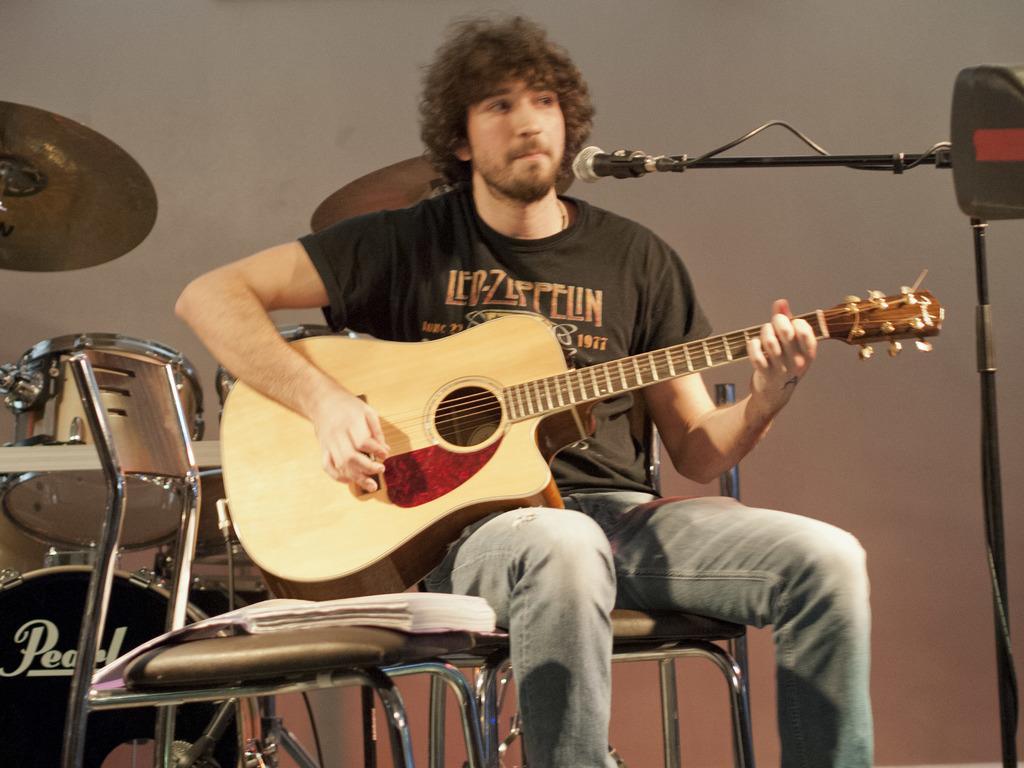Describe this image in one or two sentences. A man with black t-shirt is sitting on a chair and playing guitar. In front of his mouth there is a mic. At the back of him there are some musical instruments like drums. And beside him there is a chair. On the chair there is a book. 